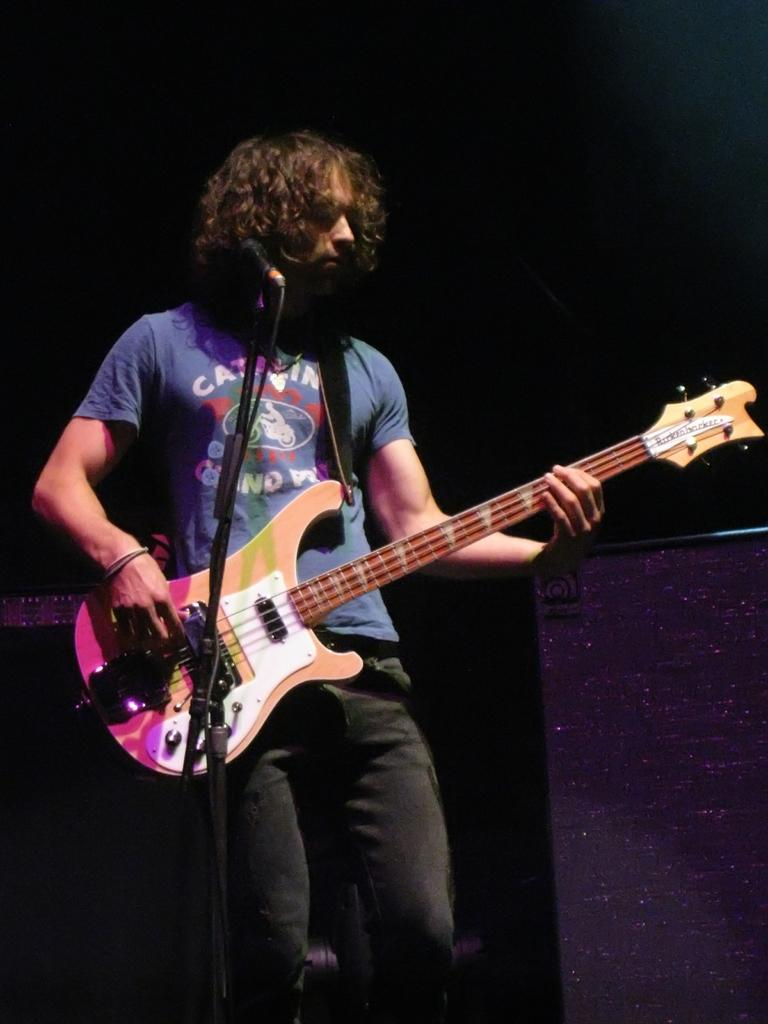Who is in the image? There is a person in the image. What is the person wearing? The person is wearing a blue t-shirt. What is the person holding? The person is holding a guitar. What object is in front of the person? There is a microphone in front of the person. What type of bat can be seen flying in the image? There is no bat present in the image. What hobbies does the person in the image have, based on the objects they are holding? We cannot determine the person's hobbies based solely on the objects they are holding in the image. 